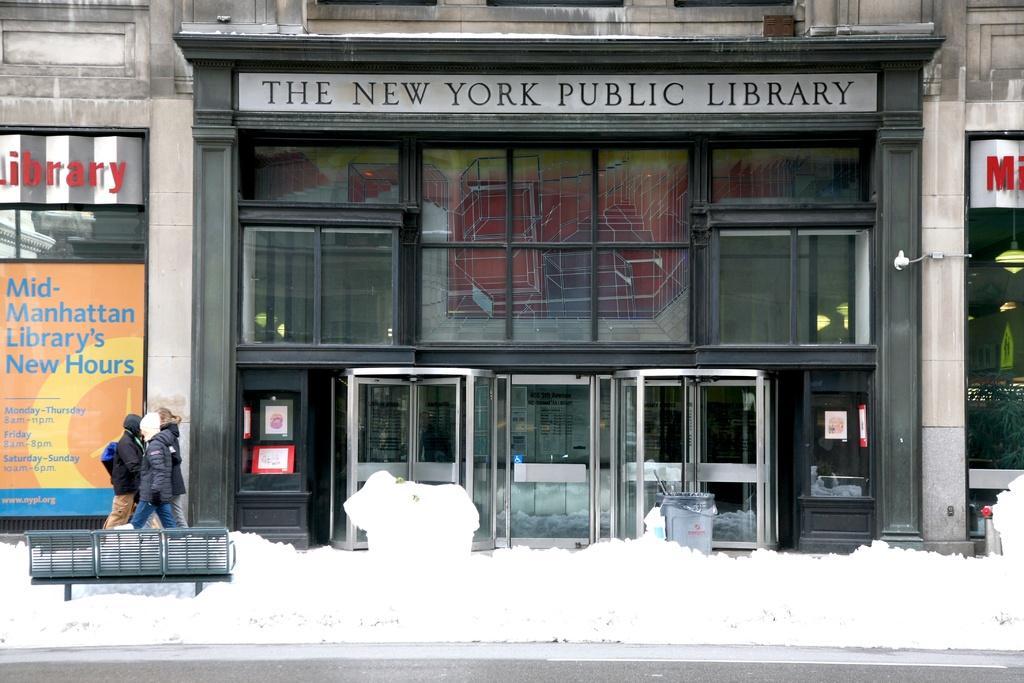In one or two sentences, can you explain what this image depicts? In this image we can see bench, some snow, there are some persons walking through the walkway and in the background of the image there is building, there are some glass doors and some posters attached to the building. 